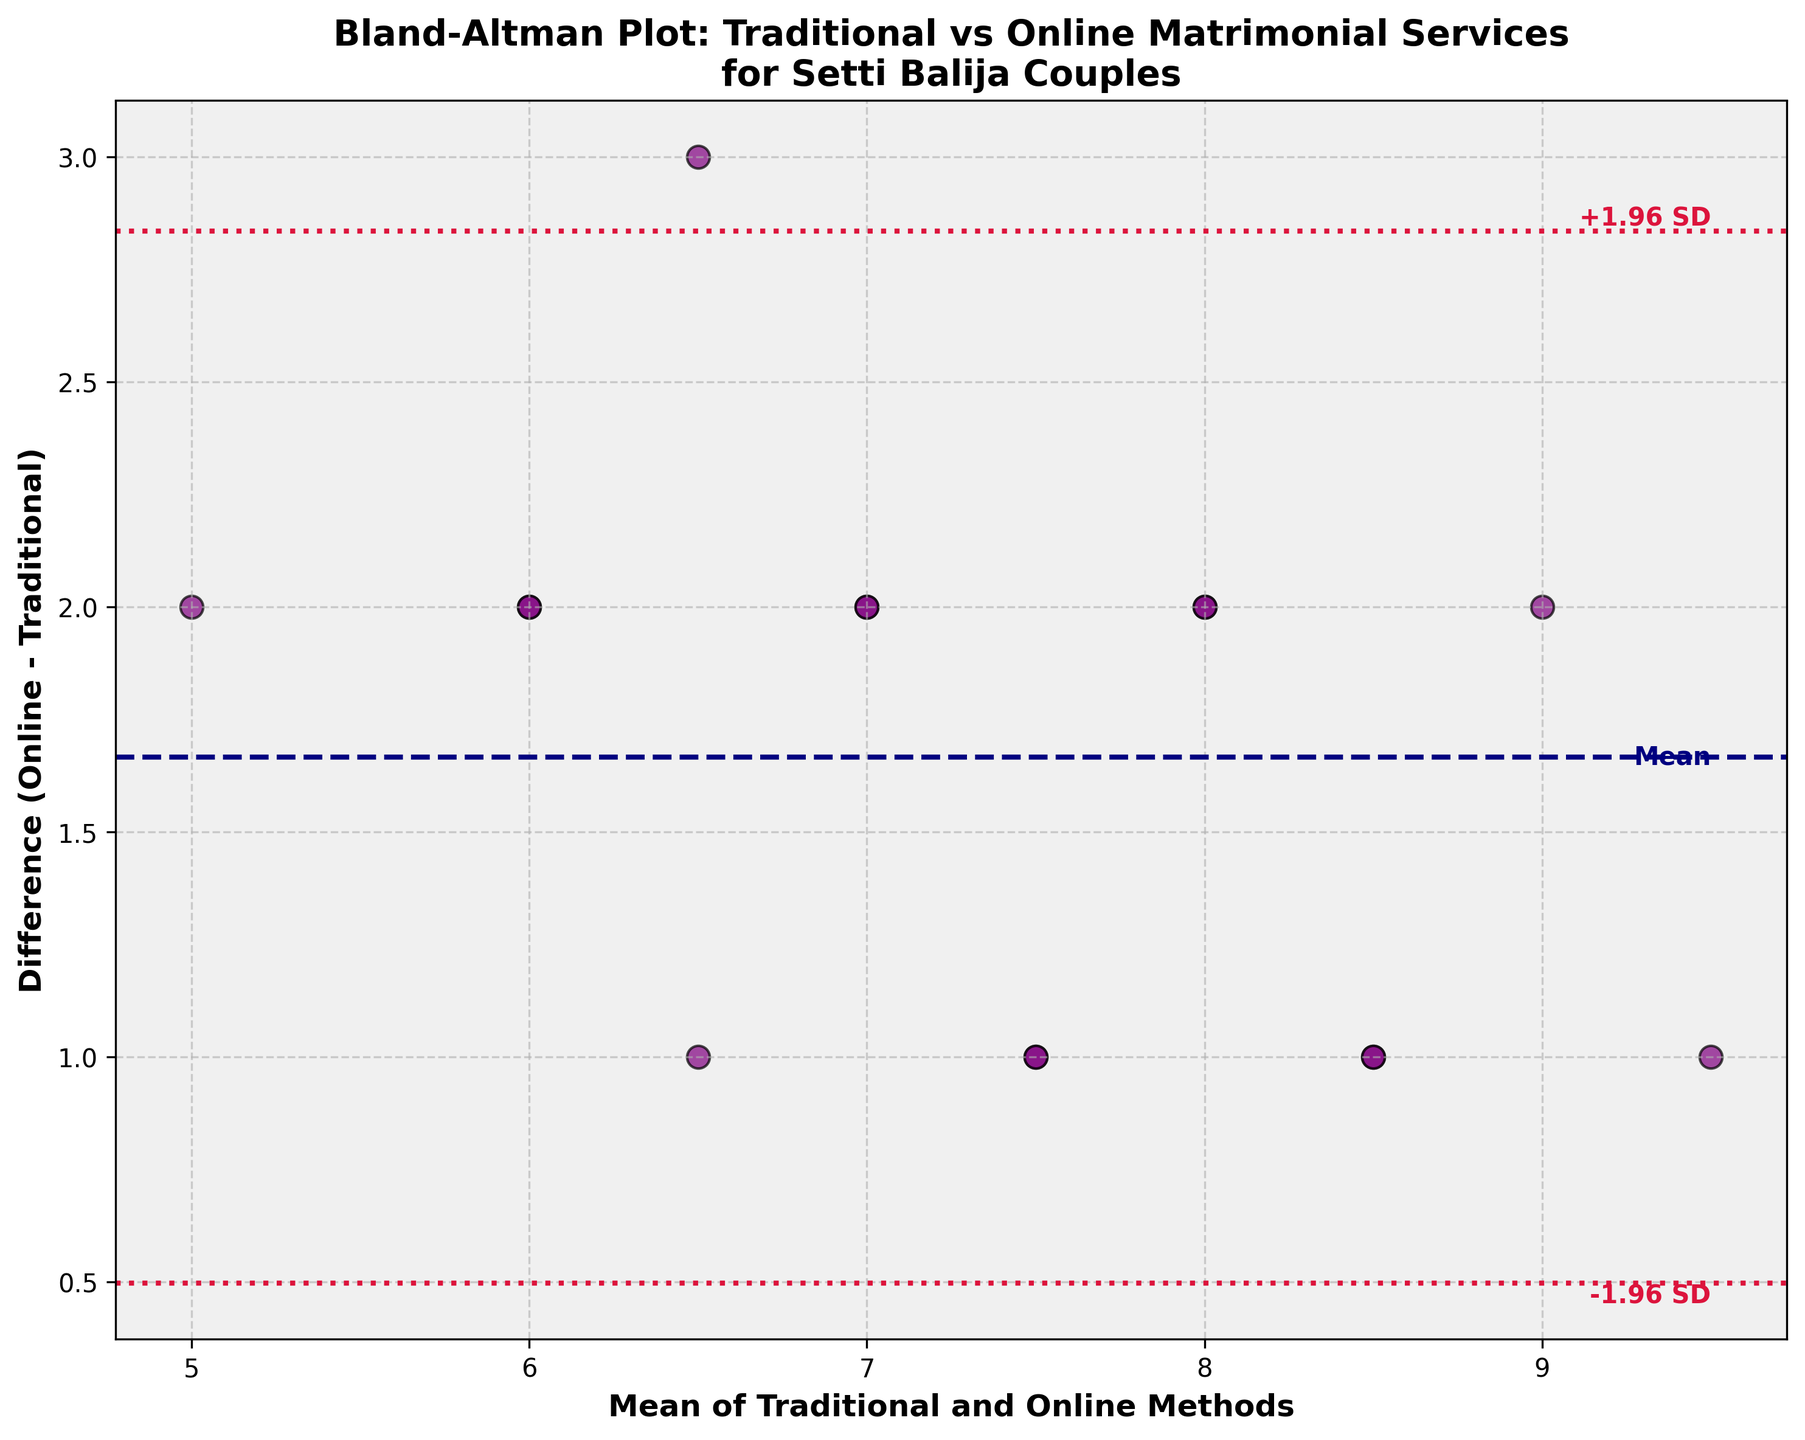What does the title of the plot indicate? The title provides information about the comparison being made in the plot. It states that the plot is a Bland-Altman plot for comparing traditional vs. online matrimonial services in matching Setti Balija couples, and highlights the focus on Setti Balija couples.
Answer: Comparison of Traditional vs. Online Matrimonial Services for Setti Balija Couples What is the mean difference line, and what is its value? The mean difference line is a horizontal line that represents the average difference between the traditional and online methods. This value is indicated by the dashed navy line. By looking at the y-value of this line, you can see that the mean difference (md) is 1.6.
Answer: 1.6 What do the dotted crimson lines represent in the plot? The dotted crimson lines represent the limits of agreement, which are computed as the mean difference plus and minus 1.96 times the standard deviation. These lines show the range within which most differences between the methods fall.
Answer: Limits of agreement How many data points lie above the mean difference line? Count the purple dots (representing the data points) that are placed above the dashed navy line which represents the mean difference of 1.6. There are 10 points above this line.
Answer: 10 What is the x-axis label and what does it represent? The x-axis label is "Mean of Traditional and Online Methods," which represents the average of the traditional and online scores for each couple.
Answer: Mean of Traditional and Online Methods By how much does the largest positive difference exceed the mean difference? The largest positive difference is 3, and the mean difference is 1.6. By subtracting the mean difference from the largest positive difference, you can see that the difference is 3 - 1.6 = 1.4.
Answer: 1.4 What is the numerical value of the lower limit of agreement? The lower limit of agreement is calculated as the mean difference minus 1.96 times the standard deviation. Using the information from the plot, the lower limit is approximately calculated as 1.6 - 1.96 * 0.489 = 0.64.
Answer: 0.64 Is there an evident trend where differences increase as the mean increases in the plot? By visually assessing the scatter of points on the plot, it can be observed whether there is a pattern indicating larger differences with increasing means. In this case, no evident trend is seen, so the differences do not appear to increase consistently with the mean.
Answer: No What range of values do the data points cover on the x-axis? The x-axis, which represents the mean of the traditional and online methods, shows a range from approximately 4.5 to 9.5, as inferred from the position of the scatter points on the plot.
Answer: 4.5 to 9.5 